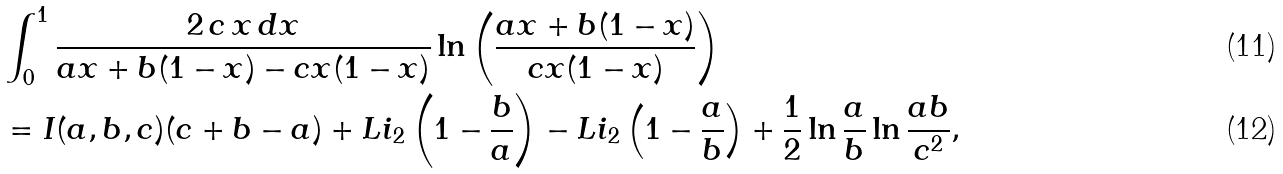Convert formula to latex. <formula><loc_0><loc_0><loc_500><loc_500>& \int _ { 0 } ^ { 1 } \frac { 2 \, c \, x \, d x } { a x + b ( 1 - x ) - c x ( 1 - x ) } \ln \left ( \frac { a x + b ( 1 - x ) } { c x ( 1 - x ) } \right ) \\ & = I ( a , b , c ) ( c + b - a ) + L i _ { 2 } \left ( 1 - \frac { b } { a } \right ) - L i _ { 2 } \left ( 1 - \frac { a } { b } \right ) + \frac { 1 } { 2 } \ln \frac { a } { b } \ln \frac { a b } { c ^ { 2 } } ,</formula> 